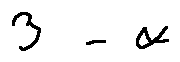<formula> <loc_0><loc_0><loc_500><loc_500>3 - \alpha</formula> 